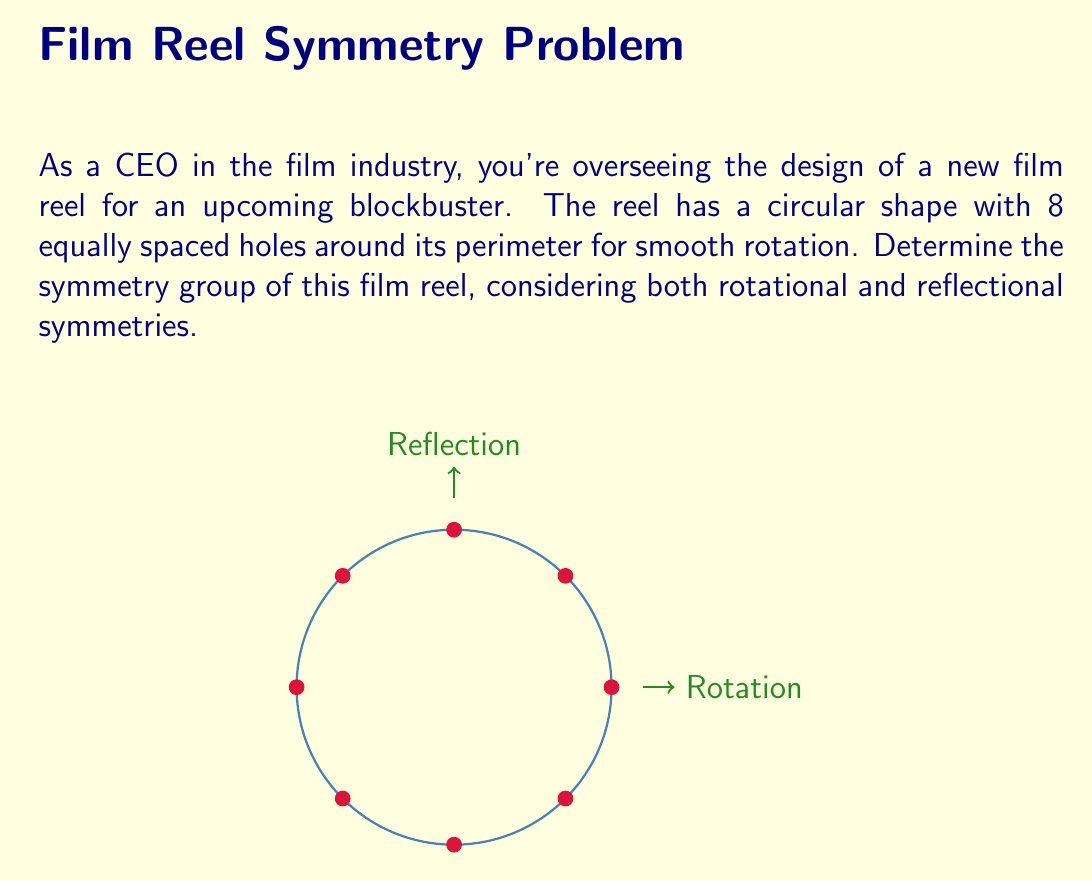Can you answer this question? Let's approach this step-by-step:

1) First, we need to identify the symmetries:

   a) Rotational symmetries: The reel can be rotated by multiples of 45° (360°/8) and still look the same. This gives us 8 rotational symmetries (including the identity rotation of 0°).

   b) Reflectional symmetries: There are 8 lines of reflection - 4 passing through opposite holes and 4 passing between adjacent holes.

2) The total number of symmetries is thus 16 (8 rotations + 8 reflections).

3) This symmetry group is known as the dihedral group of order 16, denoted as $D_8$ or $D_{16}$ (depending on the notation system).

4) The group can be generated by two elements:
   - $r$: rotation by 45°
   - $s$: reflection across a line passing through a hole

5) The group has the following properties:
   - $r^8 = e$ (identity)
   - $s^2 = e$
   - $srs = r^{-1}$

6) The elements of the group can be written as:
   $\{e, r, r^2, r^3, r^4, r^5, r^6, r^7, s, sr, sr^2, sr^3, sr^4, sr^5, sr^6, sr^7\}$

7) This group is non-abelian, as rotation followed by reflection is not always the same as reflection followed by rotation.
Answer: $D_8$ (or $D_{16}$) 